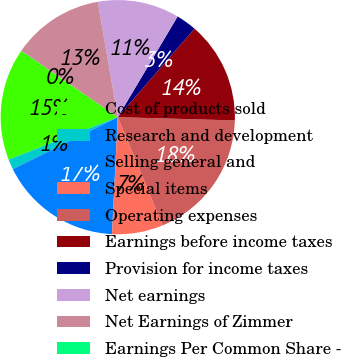Convert chart. <chart><loc_0><loc_0><loc_500><loc_500><pie_chart><fcel>Cost of products sold<fcel>Research and development<fcel>Selling general and<fcel>Special items<fcel>Operating expenses<fcel>Earnings before income taxes<fcel>Provision for income taxes<fcel>Net earnings<fcel>Net Earnings of Zimmer<fcel>Earnings Per Common Share -<nl><fcel>15.48%<fcel>1.42%<fcel>16.89%<fcel>7.05%<fcel>18.3%<fcel>14.08%<fcel>2.83%<fcel>11.27%<fcel>12.67%<fcel>0.02%<nl></chart> 